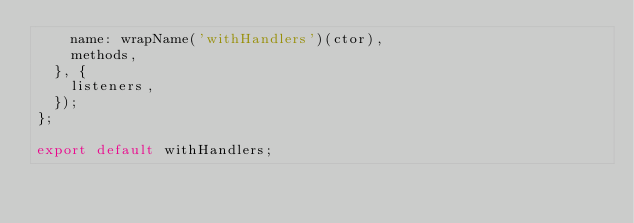<code> <loc_0><loc_0><loc_500><loc_500><_JavaScript_>    name: wrapName('withHandlers')(ctor),
    methods,
  }, {
    listeners,
  });
};

export default withHandlers;
</code> 